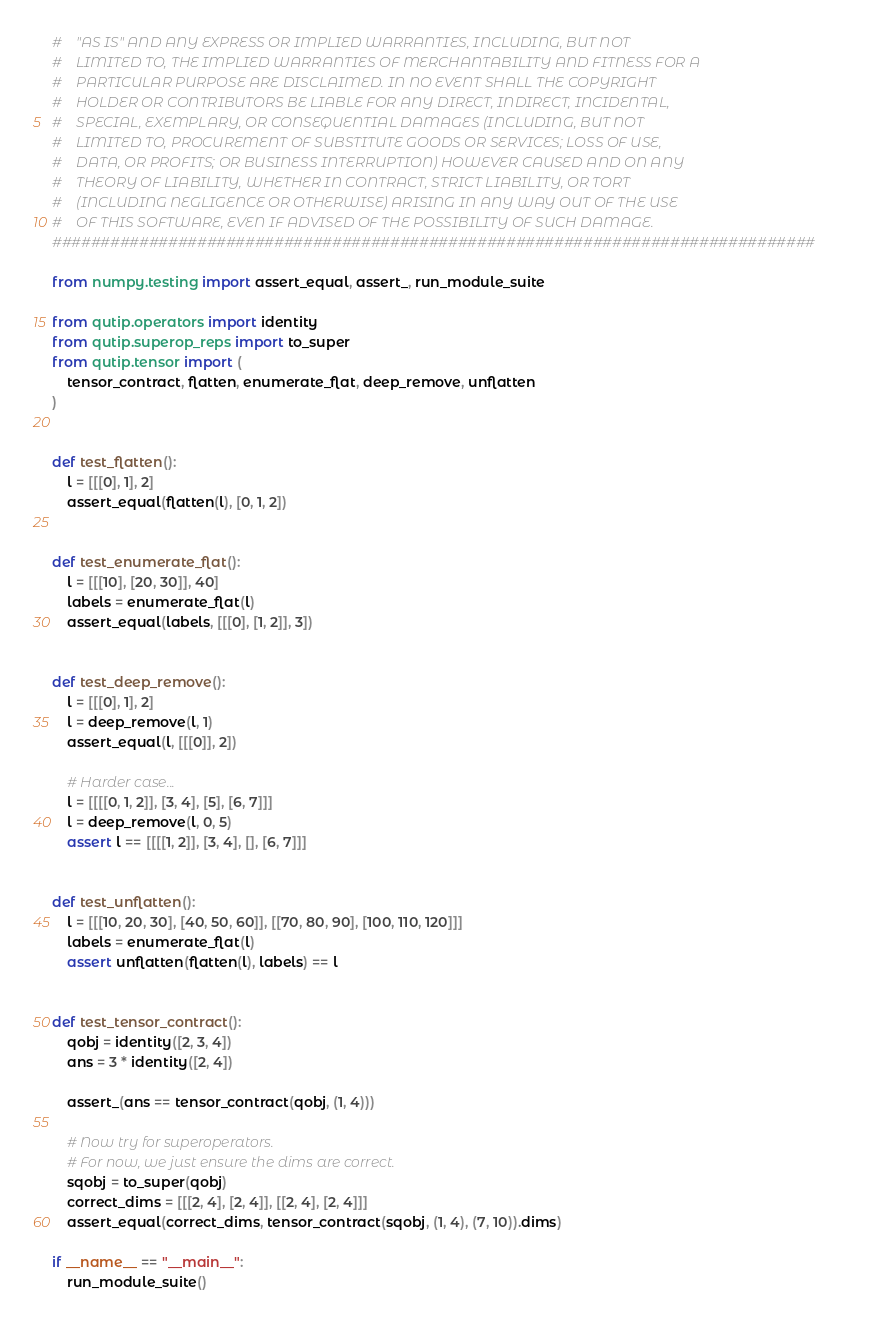<code> <loc_0><loc_0><loc_500><loc_500><_Python_>#    "AS IS" AND ANY EXPRESS OR IMPLIED WARRANTIES, INCLUDING, BUT NOT
#    LIMITED TO, THE IMPLIED WARRANTIES OF MERCHANTABILITY AND FITNESS FOR A
#    PARTICULAR PURPOSE ARE DISCLAIMED. IN NO EVENT SHALL THE COPYRIGHT
#    HOLDER OR CONTRIBUTORS BE LIABLE FOR ANY DIRECT, INDIRECT, INCIDENTAL,
#    SPECIAL, EXEMPLARY, OR CONSEQUENTIAL DAMAGES (INCLUDING, BUT NOT
#    LIMITED TO, PROCUREMENT OF SUBSTITUTE GOODS OR SERVICES; LOSS OF USE,
#    DATA, OR PROFITS; OR BUSINESS INTERRUPTION) HOWEVER CAUSED AND ON ANY
#    THEORY OF LIABILITY, WHETHER IN CONTRACT, STRICT LIABILITY, OR TORT
#    (INCLUDING NEGLIGENCE OR OTHERWISE) ARISING IN ANY WAY OUT OF THE USE
#    OF THIS SOFTWARE, EVEN IF ADVISED OF THE POSSIBILITY OF SUCH DAMAGE.
###############################################################################

from numpy.testing import assert_equal, assert_, run_module_suite

from qutip.operators import identity
from qutip.superop_reps import to_super
from qutip.tensor import (
    tensor_contract, flatten, enumerate_flat, deep_remove, unflatten
)


def test_flatten():
    l = [[[0], 1], 2]
    assert_equal(flatten(l), [0, 1, 2])


def test_enumerate_flat():
    l = [[[10], [20, 30]], 40]
    labels = enumerate_flat(l)
    assert_equal(labels, [[[0], [1, 2]], 3])


def test_deep_remove():
    l = [[[0], 1], 2]
    l = deep_remove(l, 1)
    assert_equal(l, [[[0]], 2])

    # Harder case...
    l = [[[[0, 1, 2]], [3, 4], [5], [6, 7]]]
    l = deep_remove(l, 0, 5)
    assert l == [[[[1, 2]], [3, 4], [], [6, 7]]]


def test_unflatten():
    l = [[[10, 20, 30], [40, 50, 60]], [[70, 80, 90], [100, 110, 120]]]
    labels = enumerate_flat(l)
    assert unflatten(flatten(l), labels) == l


def test_tensor_contract():
    qobj = identity([2, 3, 4])
    ans = 3 * identity([2, 4])

    assert_(ans == tensor_contract(qobj, (1, 4)))

    # Now try for superoperators.
    # For now, we just ensure the dims are correct.
    sqobj = to_super(qobj)
    correct_dims = [[[2, 4], [2, 4]], [[2, 4], [2, 4]]]
    assert_equal(correct_dims, tensor_contract(sqobj, (1, 4), (7, 10)).dims)

if __name__ == "__main__":
    run_module_suite()</code> 